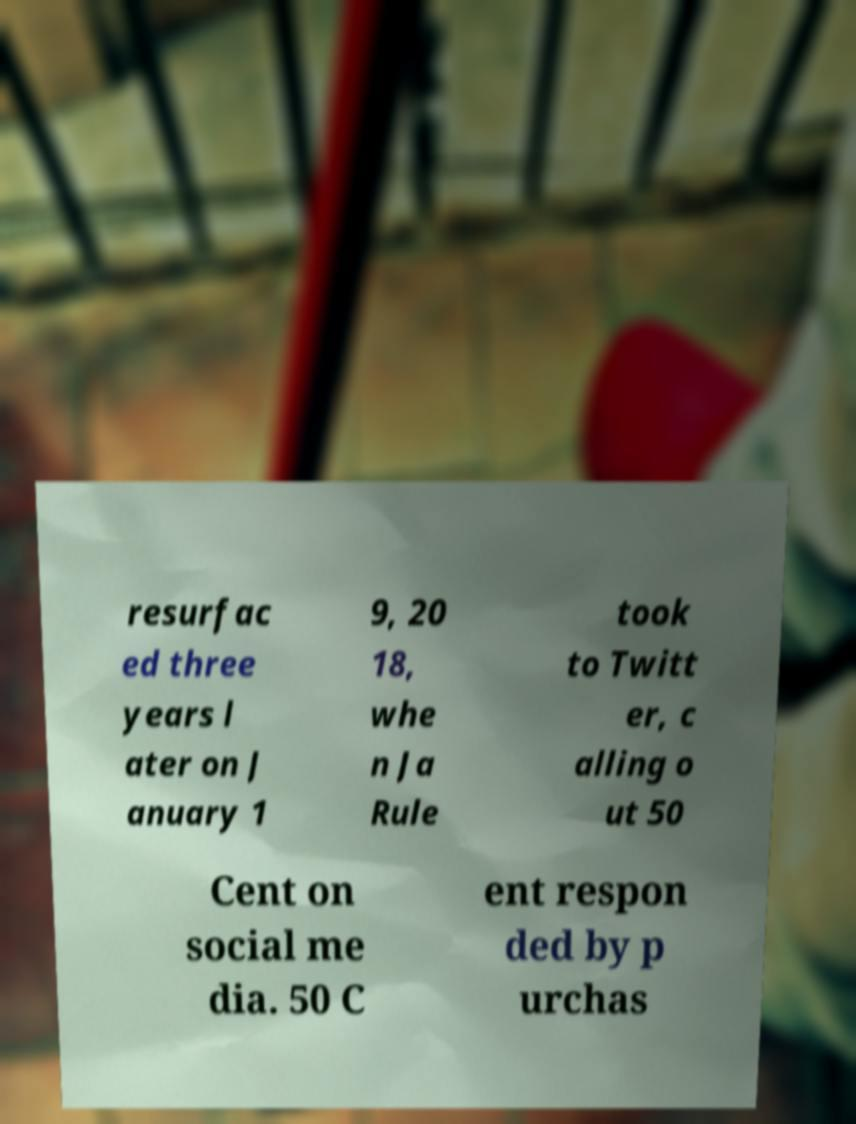Could you extract and type out the text from this image? resurfac ed three years l ater on J anuary 1 9, 20 18, whe n Ja Rule took to Twitt er, c alling o ut 50 Cent on social me dia. 50 C ent respon ded by p urchas 